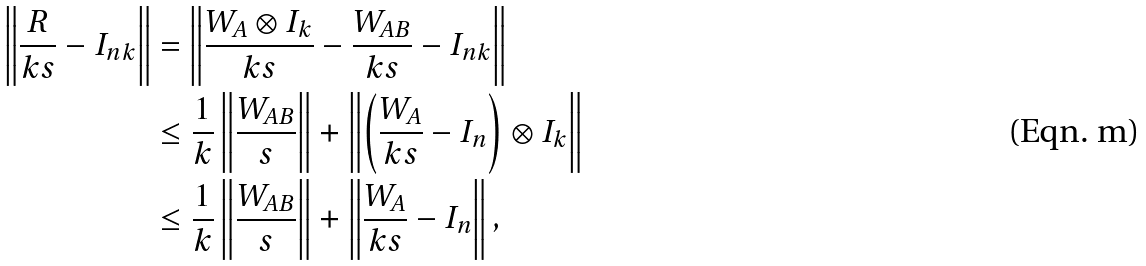<formula> <loc_0><loc_0><loc_500><loc_500>\left \| \frac { R } { k s } - I _ { n k } \right \| & = \left \| \frac { W _ { A } \otimes I _ { k } } { k s } - \frac { W _ { A B } } { k s } - I _ { n k } \right \| \\ & \leq \frac { 1 } { k } \left \| \frac { W _ { A B } } { s } \right \| + \left \| \left ( \frac { W _ { A } } { k s } - I _ { n } \right ) \otimes I _ { k } \right \| \\ & \leq \frac { 1 } { k } \left \| \frac { W _ { A B } } { s } \right \| + \left \| \frac { W _ { A } } { k s } - I _ { n } \right \| ,</formula> 